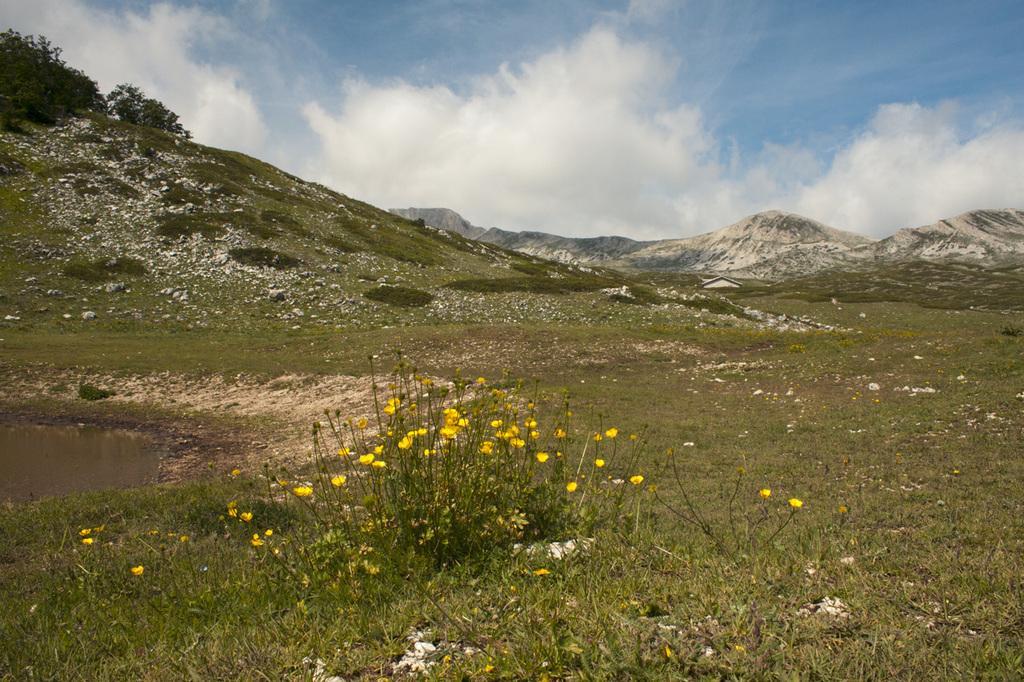Please provide a concise description of this image. In the picture I can see flower plants, the water, the grass and trees. These flowers are yellow in color. In the background I can see mountains and the sky. 